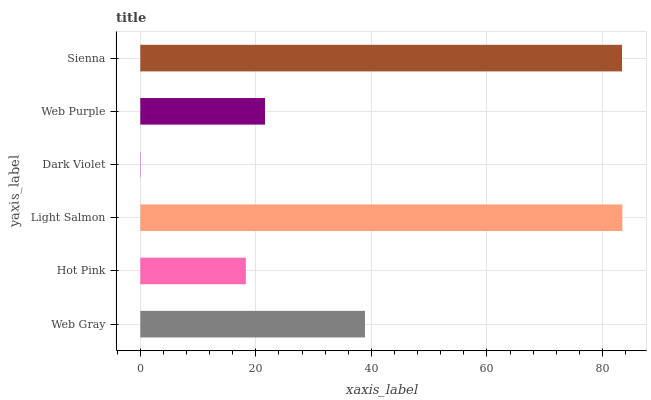Is Dark Violet the minimum?
Answer yes or no. Yes. Is Light Salmon the maximum?
Answer yes or no. Yes. Is Hot Pink the minimum?
Answer yes or no. No. Is Hot Pink the maximum?
Answer yes or no. No. Is Web Gray greater than Hot Pink?
Answer yes or no. Yes. Is Hot Pink less than Web Gray?
Answer yes or no. Yes. Is Hot Pink greater than Web Gray?
Answer yes or no. No. Is Web Gray less than Hot Pink?
Answer yes or no. No. Is Web Gray the high median?
Answer yes or no. Yes. Is Web Purple the low median?
Answer yes or no. Yes. Is Sienna the high median?
Answer yes or no. No. Is Light Salmon the low median?
Answer yes or no. No. 